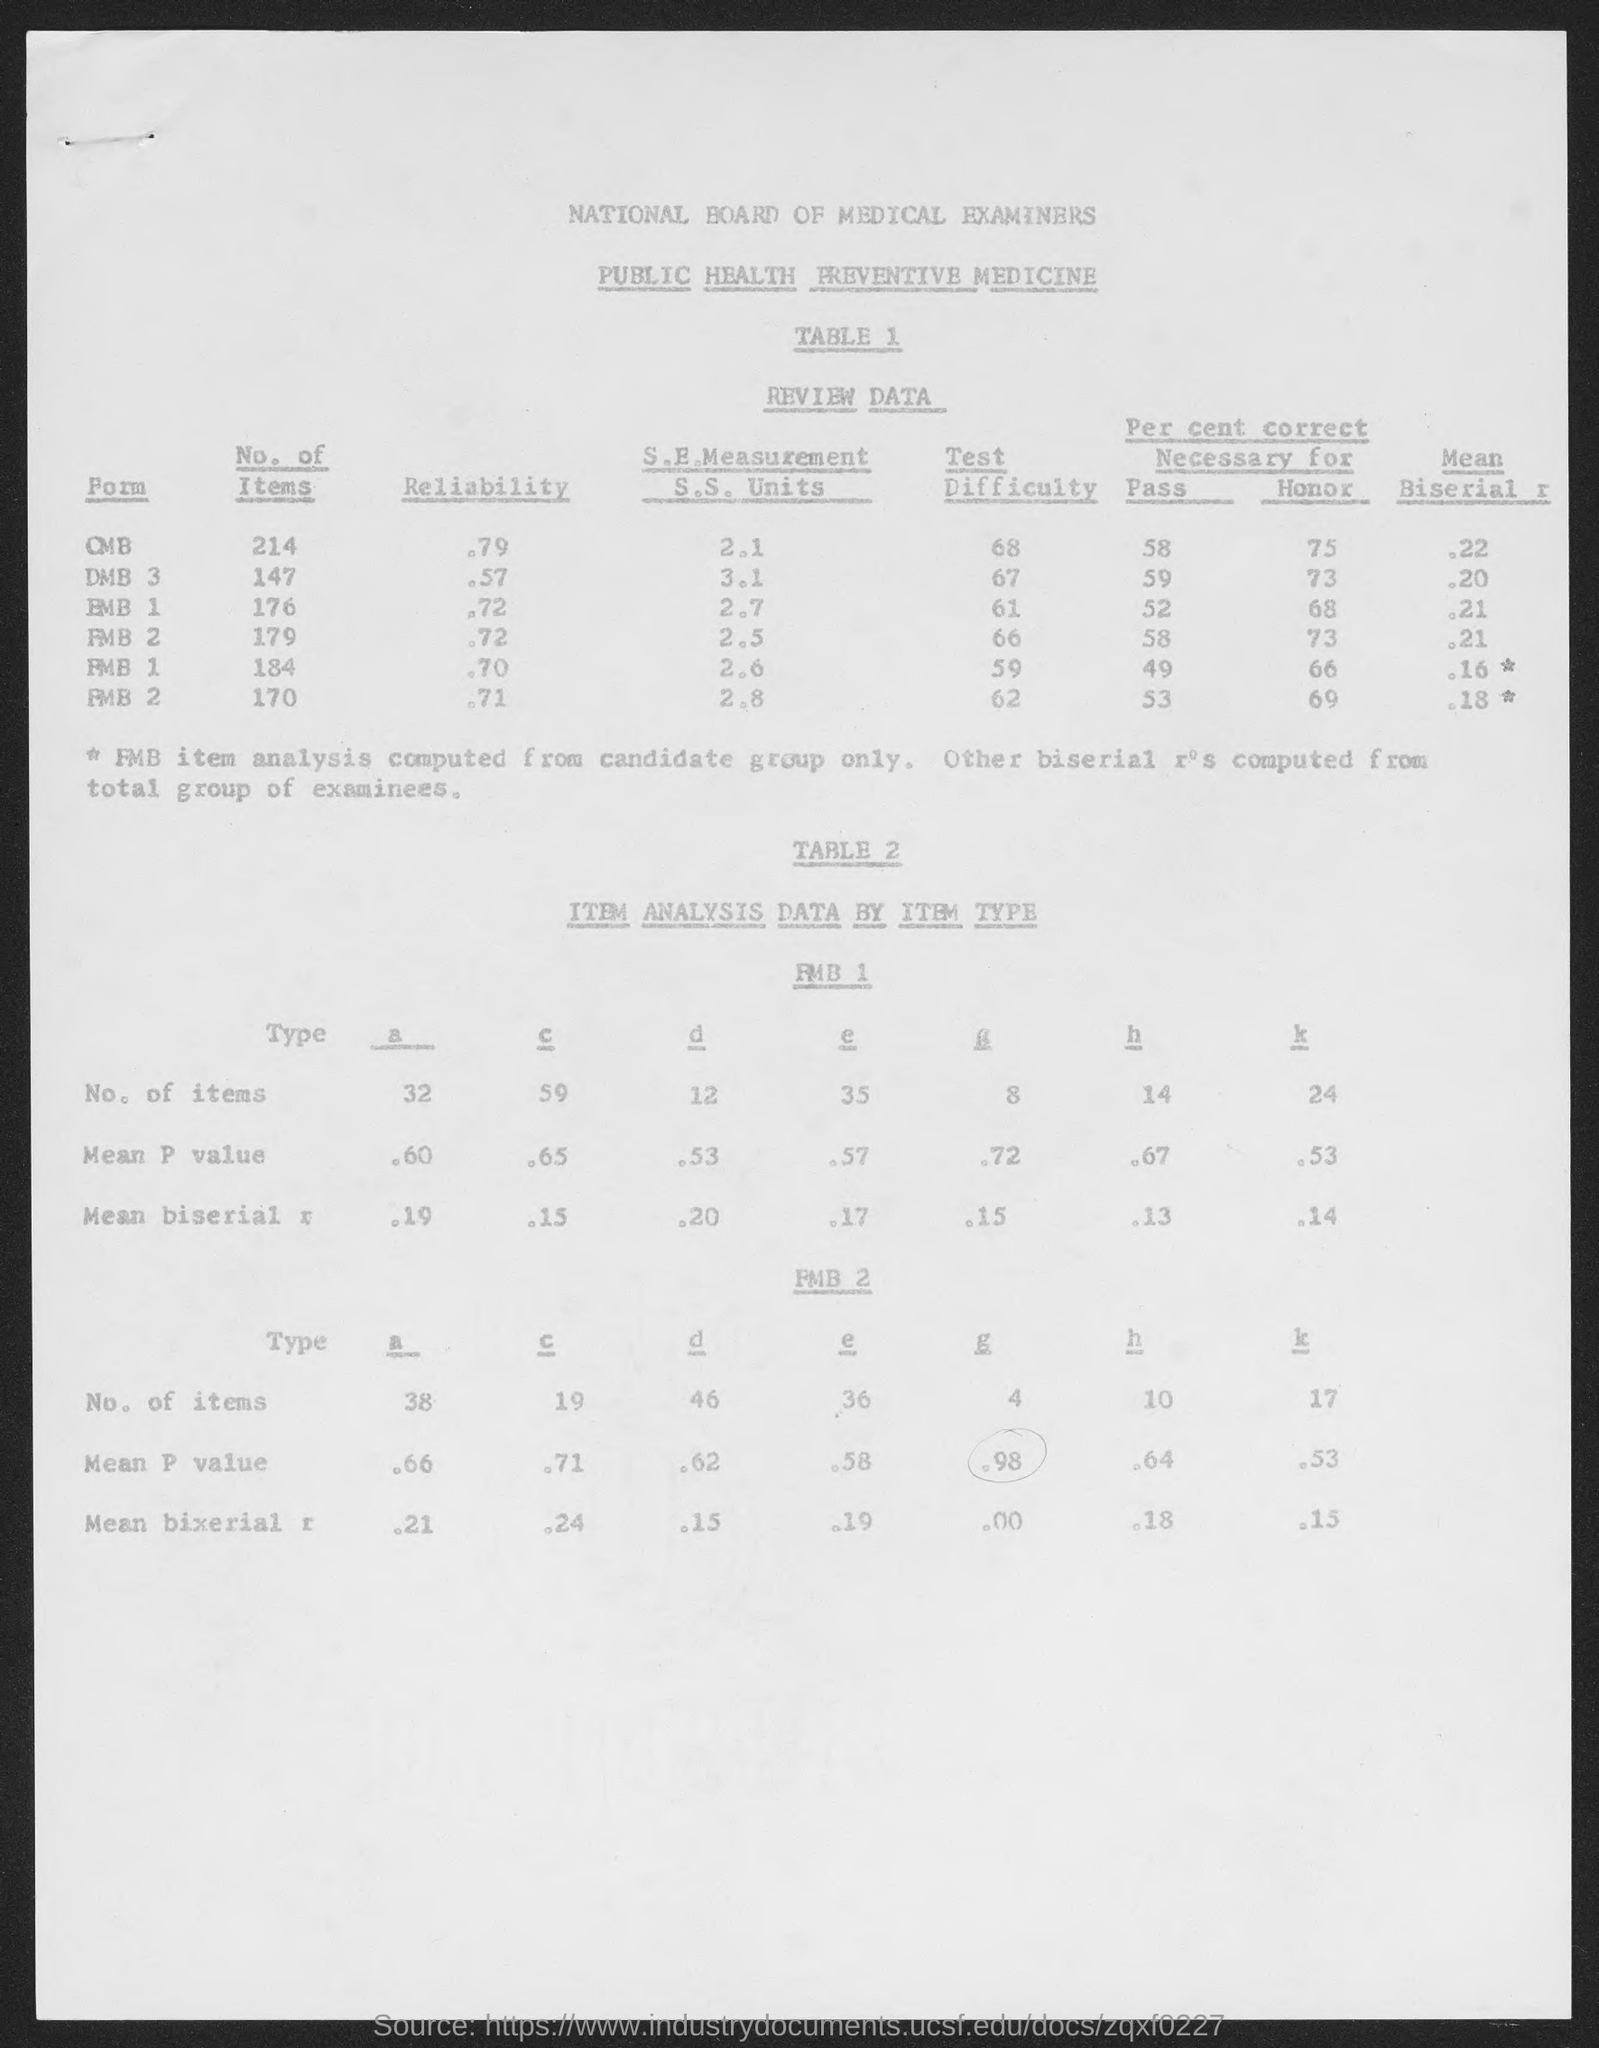Mention a couple of crucial points in this snapshot. The National Board of Medical Examiners examines public health. What is the first form in OMB?" can be rephrased as:

"What is the first form in the OMB? The heading of Table 2 is "ITEM ANALYSIS DATA BY ITEM TYPE. The form "OMB" has 214 items. The difficulty of the DMB-3 form in Table 1 is estimated to be high with a test difficulty score of 67. 